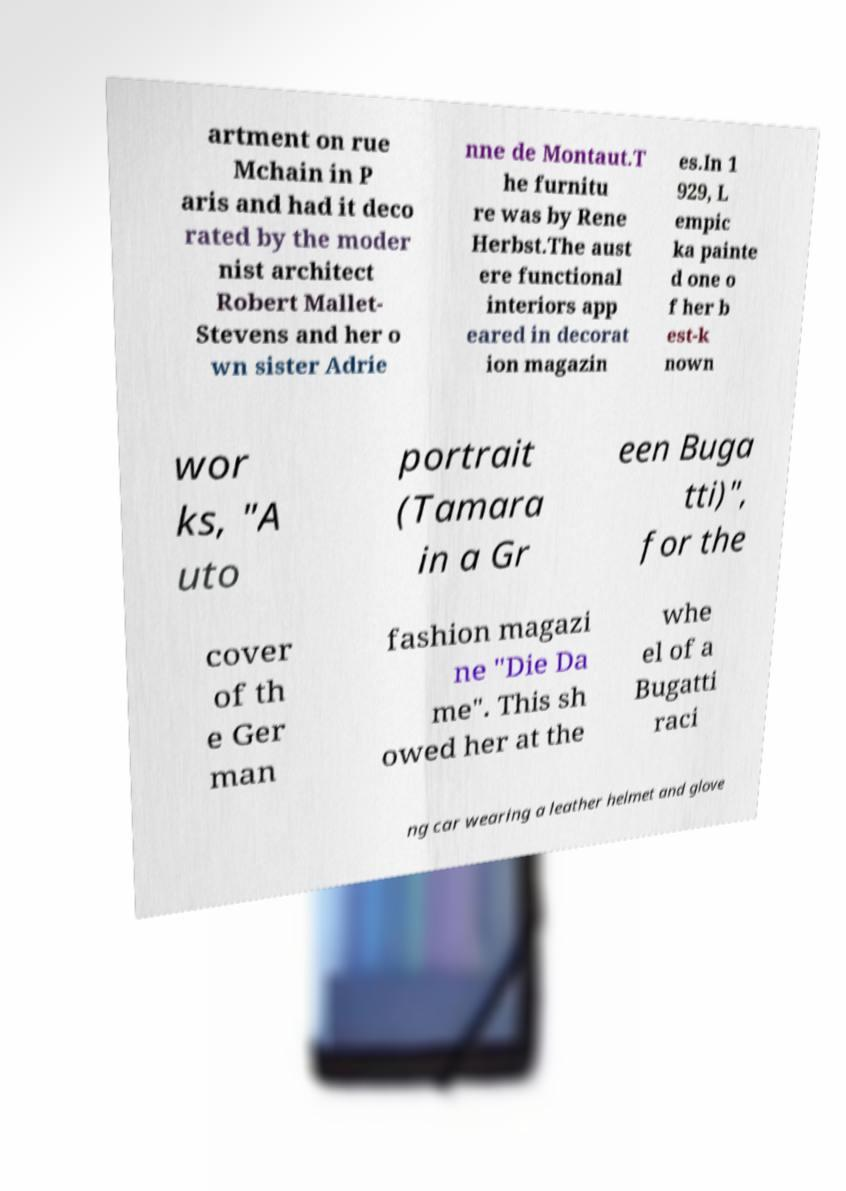Please identify and transcribe the text found in this image. artment on rue Mchain in P aris and had it deco rated by the moder nist architect Robert Mallet- Stevens and her o wn sister Adrie nne de Montaut.T he furnitu re was by Rene Herbst.The aust ere functional interiors app eared in decorat ion magazin es.In 1 929, L empic ka painte d one o f her b est-k nown wor ks, "A uto portrait (Tamara in a Gr een Buga tti)", for the cover of th e Ger man fashion magazi ne "Die Da me". This sh owed her at the whe el of a Bugatti raci ng car wearing a leather helmet and glove 